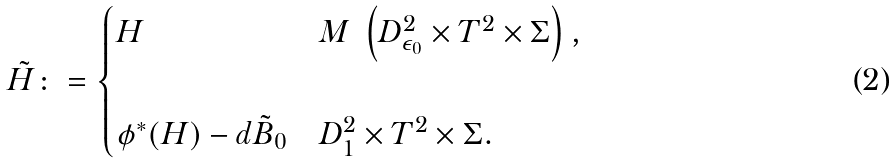<formula> <loc_0><loc_0><loc_500><loc_500>\tilde { H } \colon = \begin{cases} H & M \ \left ( D ^ { 2 } _ { \epsilon _ { 0 } } \times T ^ { 2 } \times \Sigma \right ) , \\ & \\ \phi ^ { * } ( H ) - d \tilde { B } _ { 0 } & D ^ { 2 } _ { 1 } \times T ^ { 2 } \times \Sigma . \end{cases}</formula> 